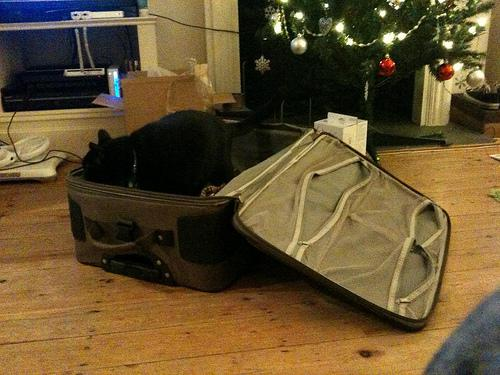Question: when is the picture taken?
Choices:
A. New Year's Eve.
B. Christmas time.
C. In the winter.
D. In the evening.
Answer with the letter. Answer: B Question: who is in the picture?
Choices:
A. Santa Clause.
B. A cat.
C. The restaurant guests.
D. A fashion model.
Answer with the letter. Answer: B Question: what is on the Christmas tree?
Choices:
A. Lights.
B. A star.
C. Ornaments.
D. Tinsel.
Answer with the letter. Answer: C Question: what animal is black?
Choices:
A. The puppy.
B. A cat.
C. The bear.
D. A bird.
Answer with the letter. Answer: B 